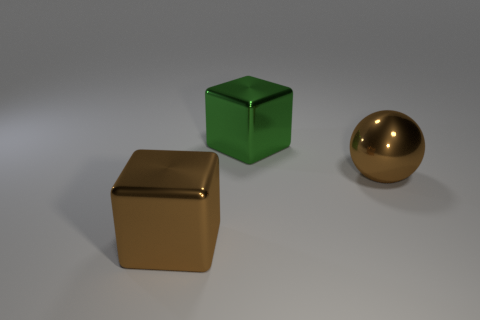Add 3 big brown metallic blocks. How many objects exist? 6 Subtract all balls. How many objects are left? 2 Subtract all green objects. Subtract all brown cubes. How many objects are left? 1 Add 2 metallic spheres. How many metallic spheres are left? 3 Add 1 big metal spheres. How many big metal spheres exist? 2 Subtract 0 gray cubes. How many objects are left? 3 